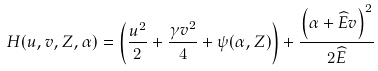<formula> <loc_0><loc_0><loc_500><loc_500>H ( u , v , Z , \alpha ) = \left ( \frac { u ^ { 2 } } { 2 } + \frac { \gamma v ^ { 2 } } { 4 } + \psi ( \alpha , Z ) \right ) + \frac { \left ( \alpha + \widehat { E } v \right ) ^ { 2 } } { 2 \widehat { E } }</formula> 